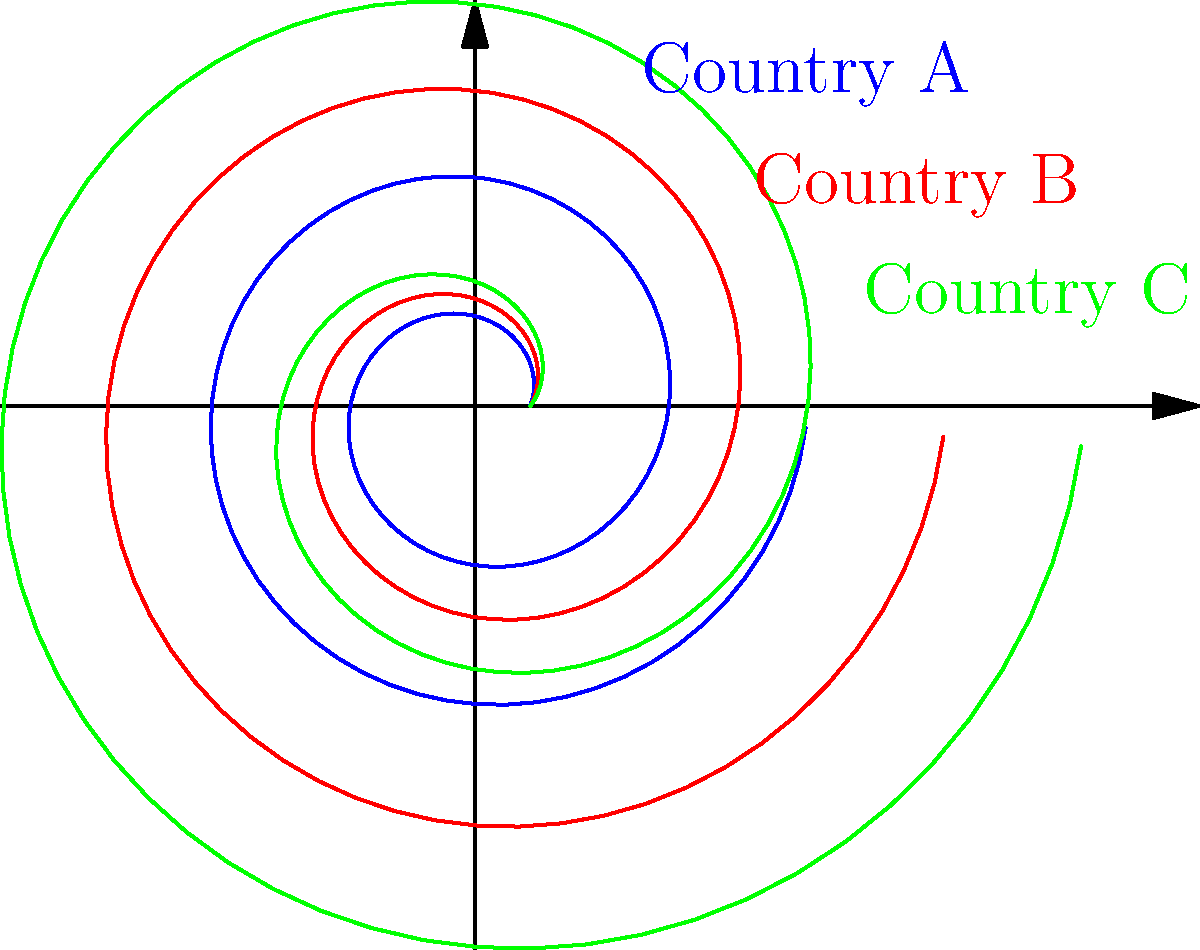The spiral graphs represent wealth concentration in three countries, where a tighter spiral indicates higher inequality. Based on the graph, which country has the highest level of economic inequality, and how might this information be used to advocate for policy changes on your blog? To answer this question, we need to analyze the spiral graphs for each country:

1. Interpret the spirals:
   - A tighter spiral (closer turns) represents higher inequality.
   - A looser spiral (wider turns) represents lower inequality.

2. Compare the spirals:
   - Country A (blue): Tightest spiral
   - Country B (red): Medium spiral
   - Country C (green): Loosest spiral

3. Determine the highest inequality:
   Country A has the tightest spiral, indicating the highest level of economic inequality.

4. Using this information for advocacy:
   - Highlight the stark contrast between Country A and Countries B and C.
   - Use Country A as an example of extreme inequality in blog posts.
   - Compare policies in Country A with those in Countries B and C to identify potential areas for reform.
   - Advocate for policy changes in Country A, such as:
     a) Progressive taxation
     b) Increased social spending
     c) Improved access to education and healthcare
   - Use the visual representation to make the data more accessible and impactful for your audience.
Answer: Country A; use as example to advocate for policy reforms addressing wealth inequality. 